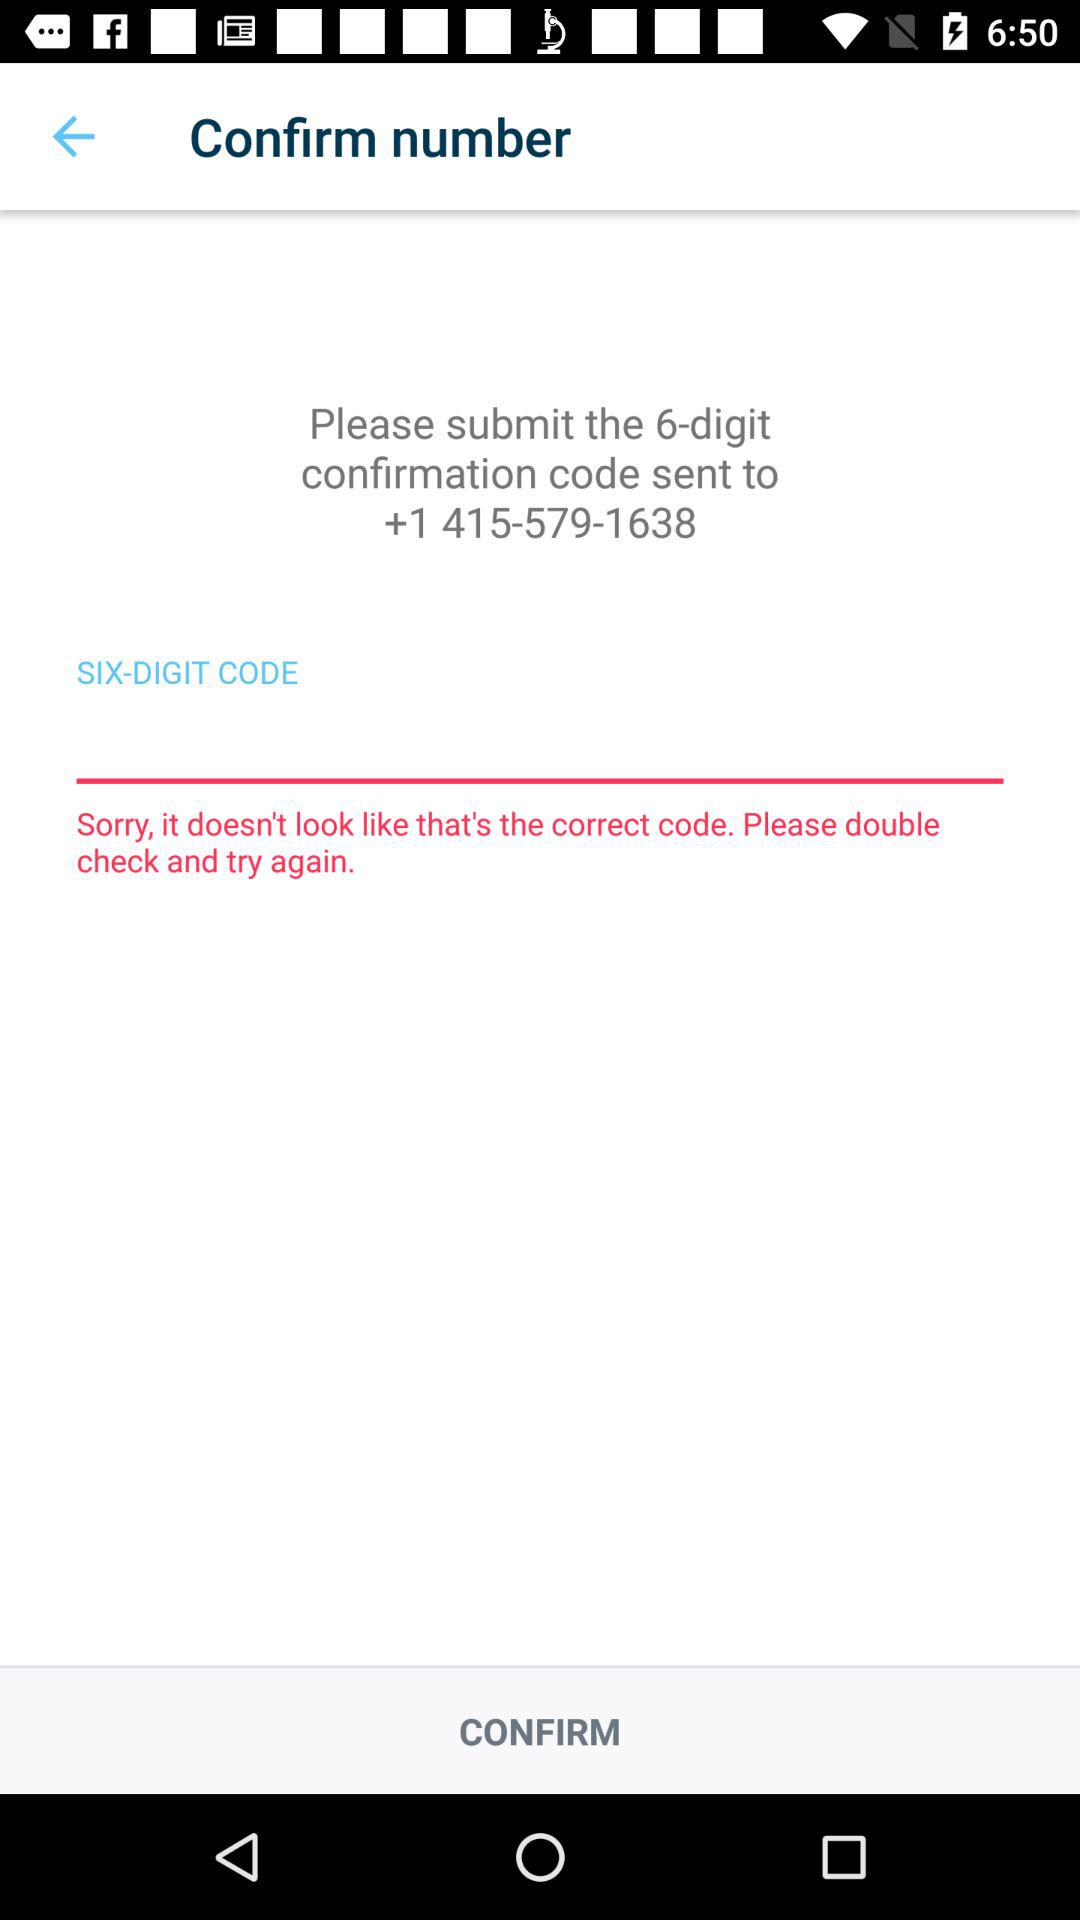What's the contact number mentioned for receiving the code? The contact number is +1 415-579-1638. 